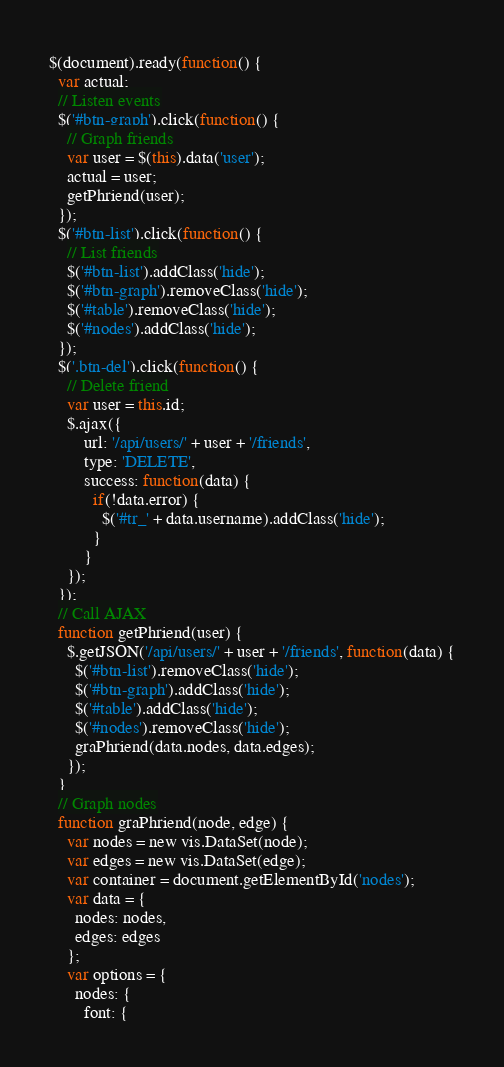Convert code to text. <code><loc_0><loc_0><loc_500><loc_500><_JavaScript_>$(document).ready(function() {
  var actual;
  // Listen events
  $('#btn-graph').click(function() {
    // Graph friends
    var user = $(this).data('user');
    actual = user;
    getPhriend(user);
  });
  $('#btn-list').click(function() {
    // List friends
    $('#btn-list').addClass('hide');
    $('#btn-graph').removeClass('hide');
    $('#table').removeClass('hide');
    $('#nodes').addClass('hide');
  });
  $('.btn-del').click(function() {
    // Delete friend
    var user = this.id;
    $.ajax({
        url: '/api/users/' + user + '/friends',
        type: 'DELETE',
        success: function(data) {
          if(!data.error) {
            $('#tr_' + data.username).addClass('hide');
          }
        }
    });
  });
  // Call AJAX
  function getPhriend(user) {
    $.getJSON('/api/users/' + user + '/friends', function(data) {
      $('#btn-list').removeClass('hide');
      $('#btn-graph').addClass('hide');
      $('#table').addClass('hide');
      $('#nodes').removeClass('hide');
      graPhriend(data.nodes, data.edges);
    });
  }
  // Graph nodes
  function graPhriend(node, edge) {
    var nodes = new vis.DataSet(node);
    var edges = new vis.DataSet(edge);
    var container = document.getElementById('nodes');
    var data = {
      nodes: nodes,
      edges: edges
    };
    var options = {
      nodes: {
        font: {</code> 